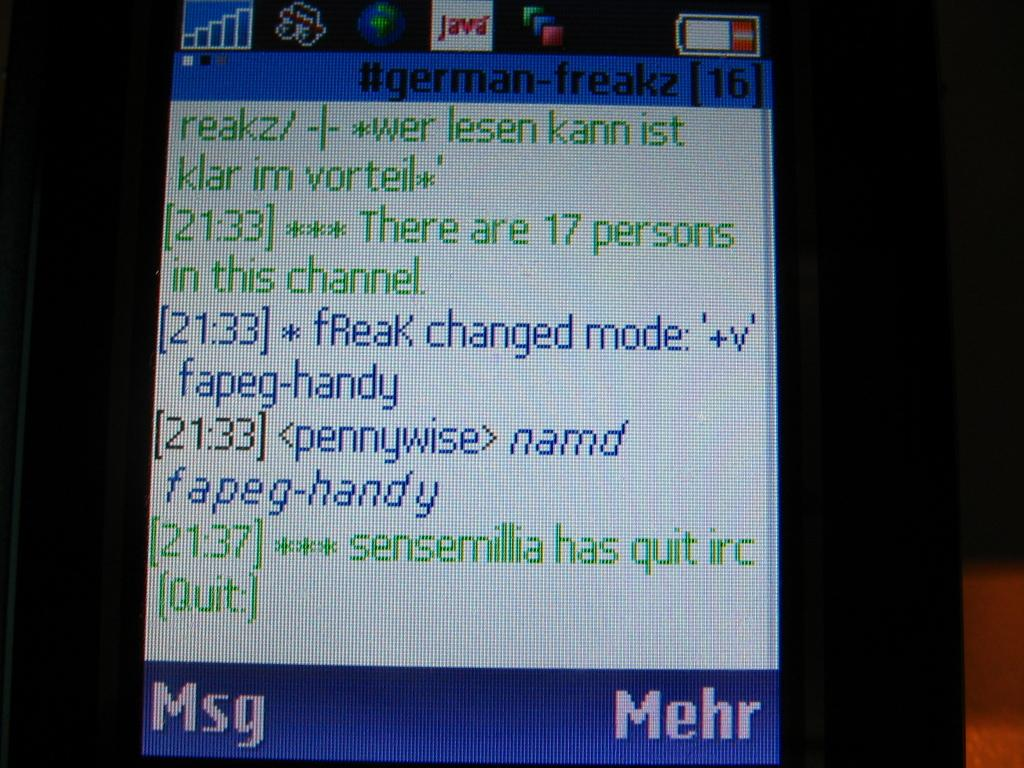<image>
Render a clear and concise summary of the photo. Screen with the number 16 on top and the word  "german-freakz" as well. 